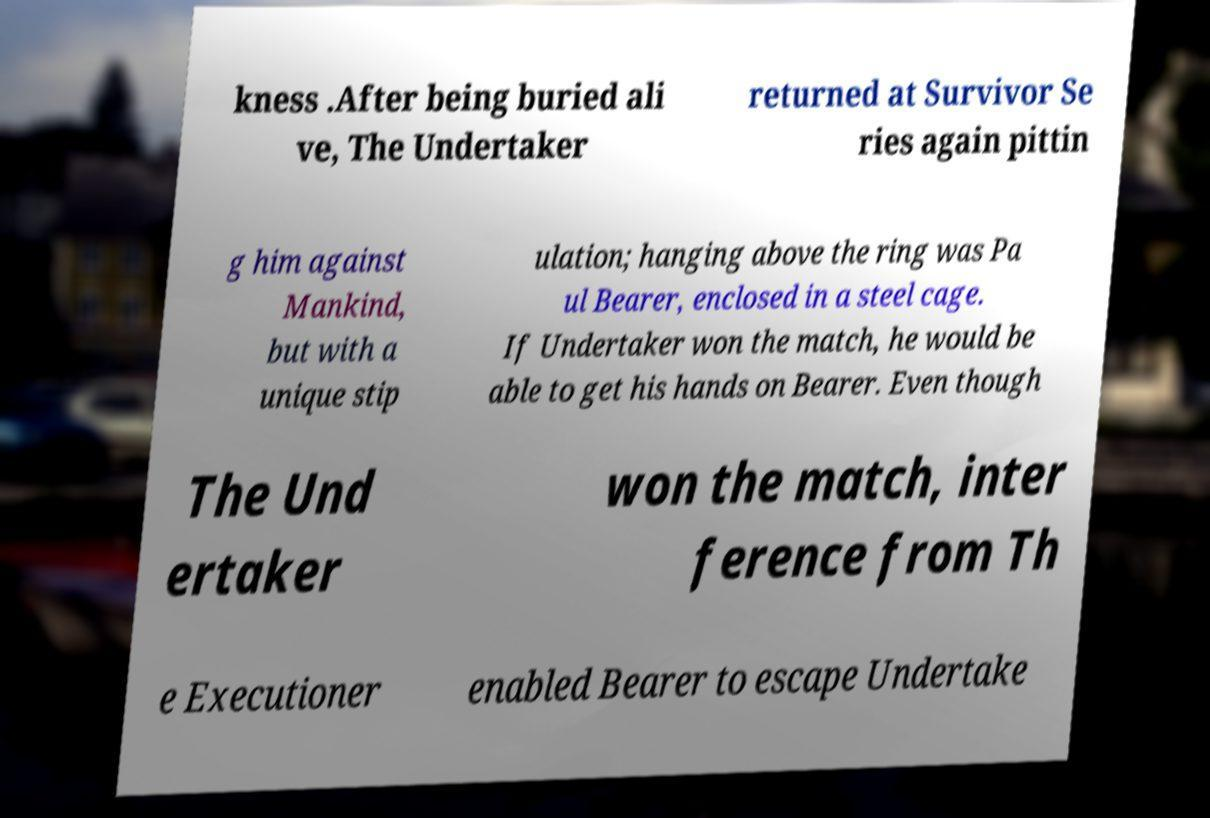Please read and relay the text visible in this image. What does it say? kness .After being buried ali ve, The Undertaker returned at Survivor Se ries again pittin g him against Mankind, but with a unique stip ulation; hanging above the ring was Pa ul Bearer, enclosed in a steel cage. If Undertaker won the match, he would be able to get his hands on Bearer. Even though The Und ertaker won the match, inter ference from Th e Executioner enabled Bearer to escape Undertake 